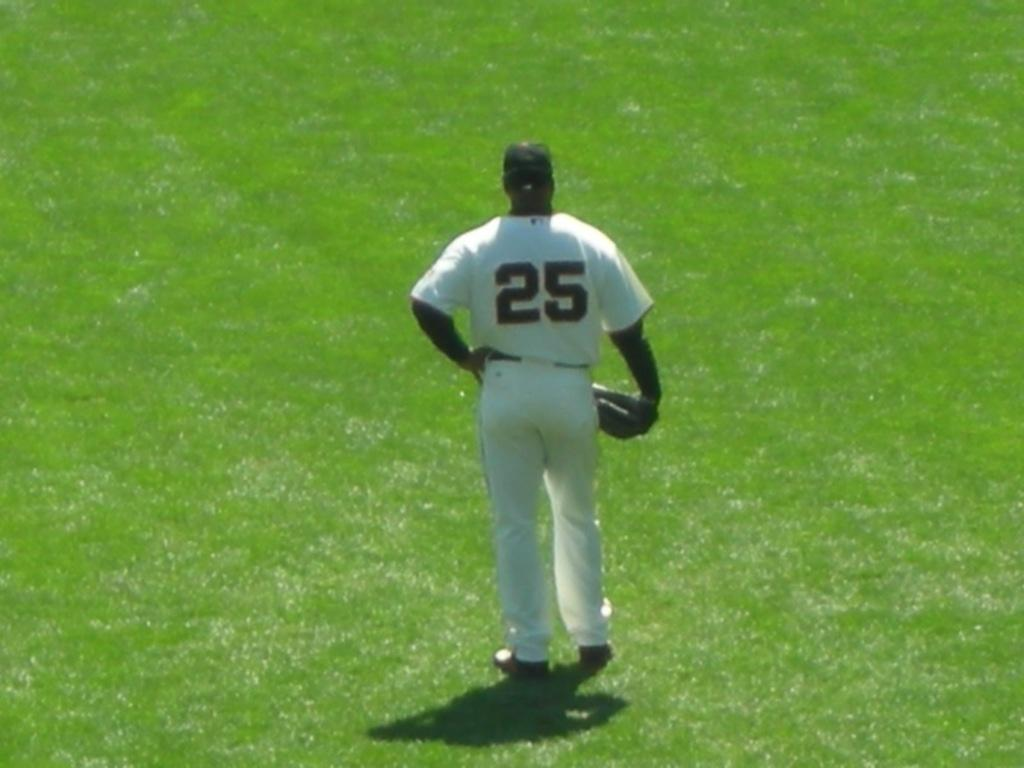Provide a one-sentence caption for the provided image. The baseball player's shirt is number twenty five. 